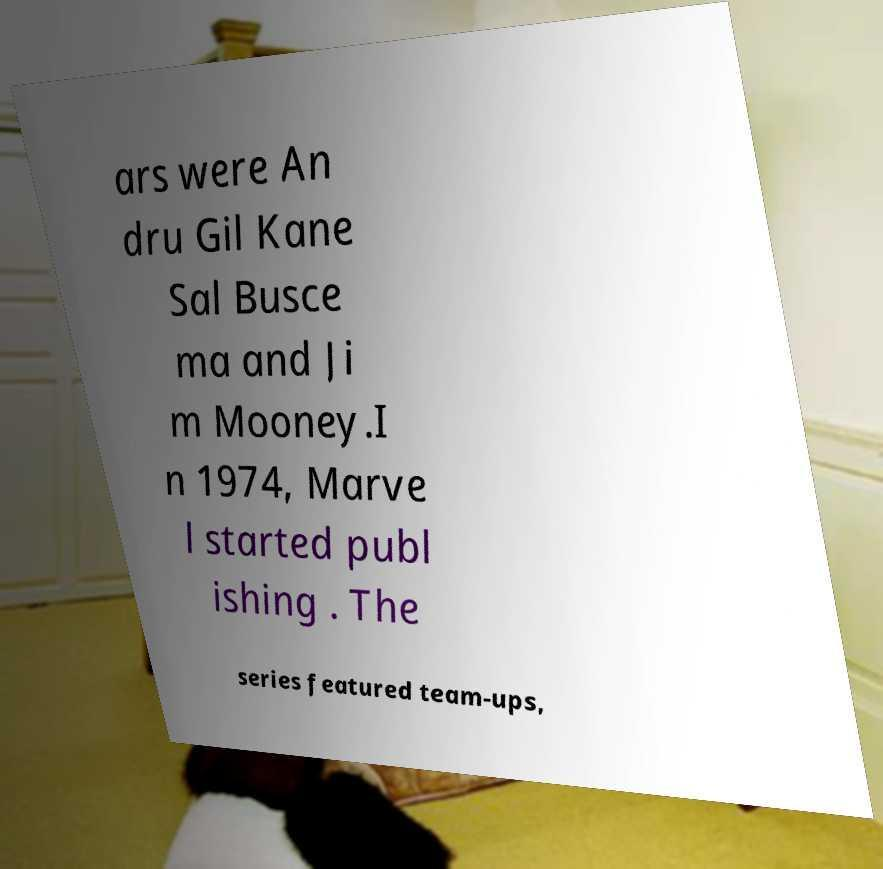Can you accurately transcribe the text from the provided image for me? ars were An dru Gil Kane Sal Busce ma and Ji m Mooney.I n 1974, Marve l started publ ishing . The series featured team-ups, 